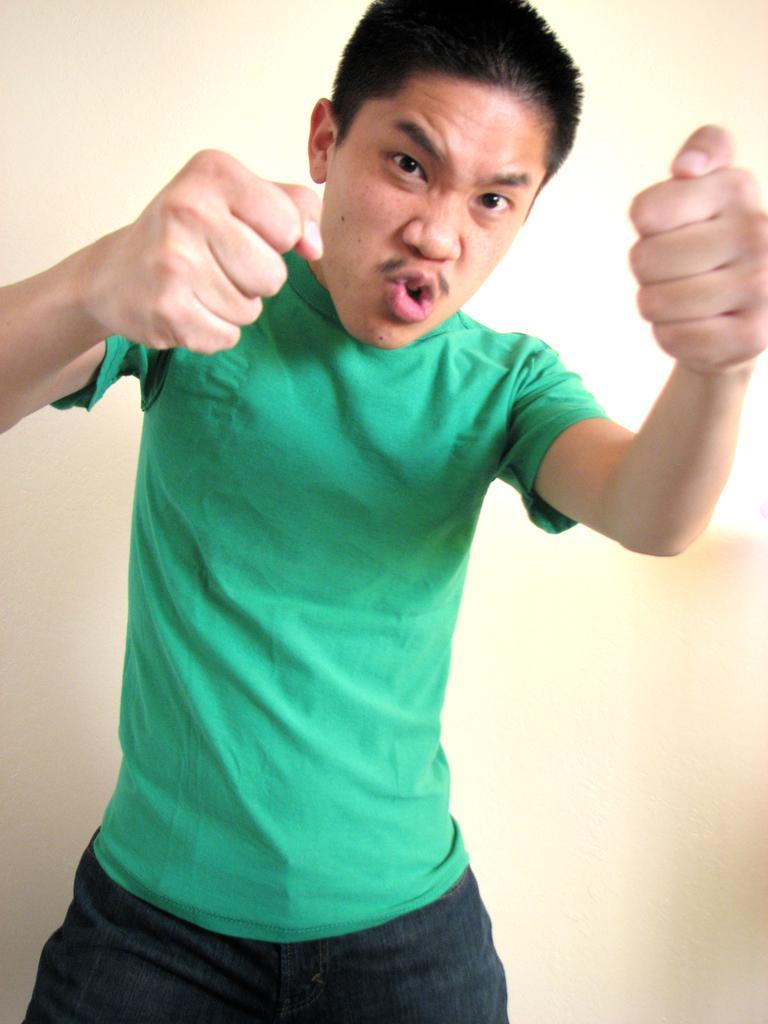Describe this image in one or two sentences. In this image we can see a person wearing a green t shirt is standing. 